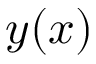<formula> <loc_0><loc_0><loc_500><loc_500>y ( x )</formula> 